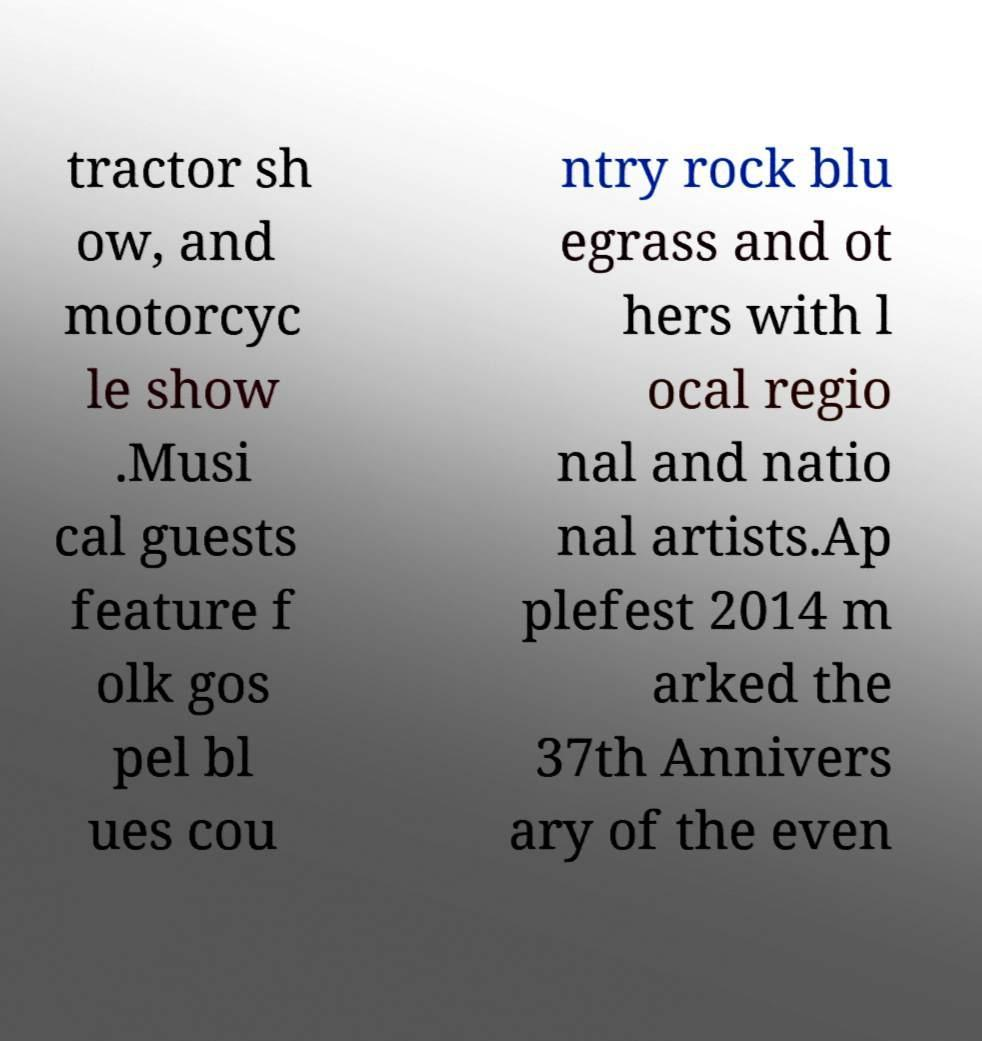What messages or text are displayed in this image? I need them in a readable, typed format. tractor sh ow, and motorcyc le show .Musi cal guests feature f olk gos pel bl ues cou ntry rock blu egrass and ot hers with l ocal regio nal and natio nal artists.Ap plefest 2014 m arked the 37th Annivers ary of the even 